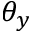Convert formula to latex. <formula><loc_0><loc_0><loc_500><loc_500>\theta _ { y }</formula> 